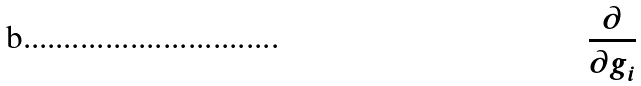<formula> <loc_0><loc_0><loc_500><loc_500>\frac { \partial } { \partial g _ { i } }</formula> 